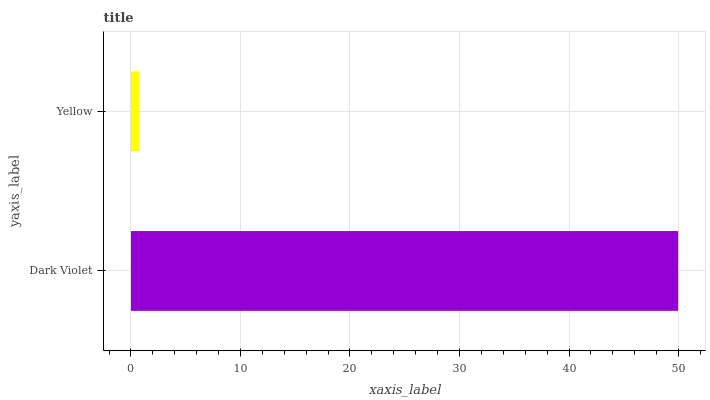Is Yellow the minimum?
Answer yes or no. Yes. Is Dark Violet the maximum?
Answer yes or no. Yes. Is Yellow the maximum?
Answer yes or no. No. Is Dark Violet greater than Yellow?
Answer yes or no. Yes. Is Yellow less than Dark Violet?
Answer yes or no. Yes. Is Yellow greater than Dark Violet?
Answer yes or no. No. Is Dark Violet less than Yellow?
Answer yes or no. No. Is Dark Violet the high median?
Answer yes or no. Yes. Is Yellow the low median?
Answer yes or no. Yes. Is Yellow the high median?
Answer yes or no. No. Is Dark Violet the low median?
Answer yes or no. No. 